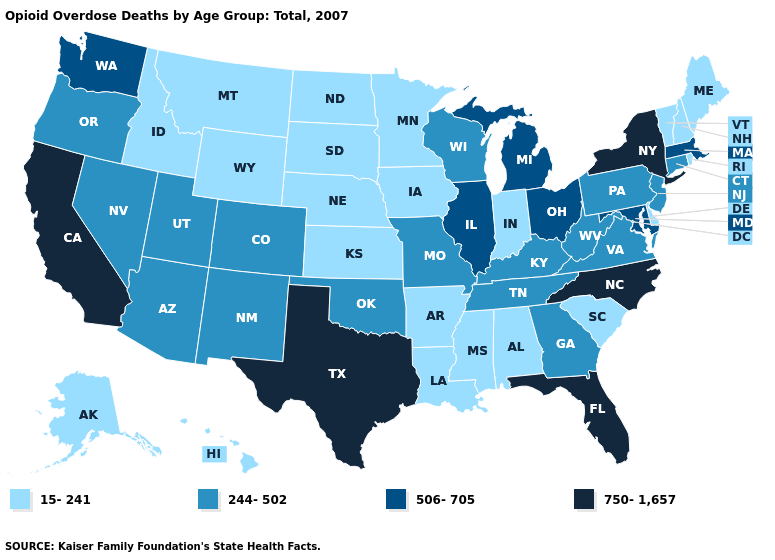Is the legend a continuous bar?
Be succinct. No. Does Iowa have the lowest value in the USA?
Keep it brief. Yes. Does Wyoming have a higher value than Connecticut?
Be succinct. No. What is the value of Colorado?
Quick response, please. 244-502. What is the lowest value in states that border Nevada?
Concise answer only. 15-241. Among the states that border New Jersey , which have the lowest value?
Keep it brief. Delaware. Name the states that have a value in the range 15-241?
Answer briefly. Alabama, Alaska, Arkansas, Delaware, Hawaii, Idaho, Indiana, Iowa, Kansas, Louisiana, Maine, Minnesota, Mississippi, Montana, Nebraska, New Hampshire, North Dakota, Rhode Island, South Carolina, South Dakota, Vermont, Wyoming. Name the states that have a value in the range 506-705?
Concise answer only. Illinois, Maryland, Massachusetts, Michigan, Ohio, Washington. What is the value of Oklahoma?
Quick response, please. 244-502. What is the lowest value in the USA?
Keep it brief. 15-241. Which states have the lowest value in the USA?
Write a very short answer. Alabama, Alaska, Arkansas, Delaware, Hawaii, Idaho, Indiana, Iowa, Kansas, Louisiana, Maine, Minnesota, Mississippi, Montana, Nebraska, New Hampshire, North Dakota, Rhode Island, South Carolina, South Dakota, Vermont, Wyoming. Name the states that have a value in the range 15-241?
Answer briefly. Alabama, Alaska, Arkansas, Delaware, Hawaii, Idaho, Indiana, Iowa, Kansas, Louisiana, Maine, Minnesota, Mississippi, Montana, Nebraska, New Hampshire, North Dakota, Rhode Island, South Carolina, South Dakota, Vermont, Wyoming. What is the highest value in the West ?
Short answer required. 750-1,657. What is the value of North Dakota?
Short answer required. 15-241. Does South Carolina have a higher value than Nevada?
Short answer required. No. 